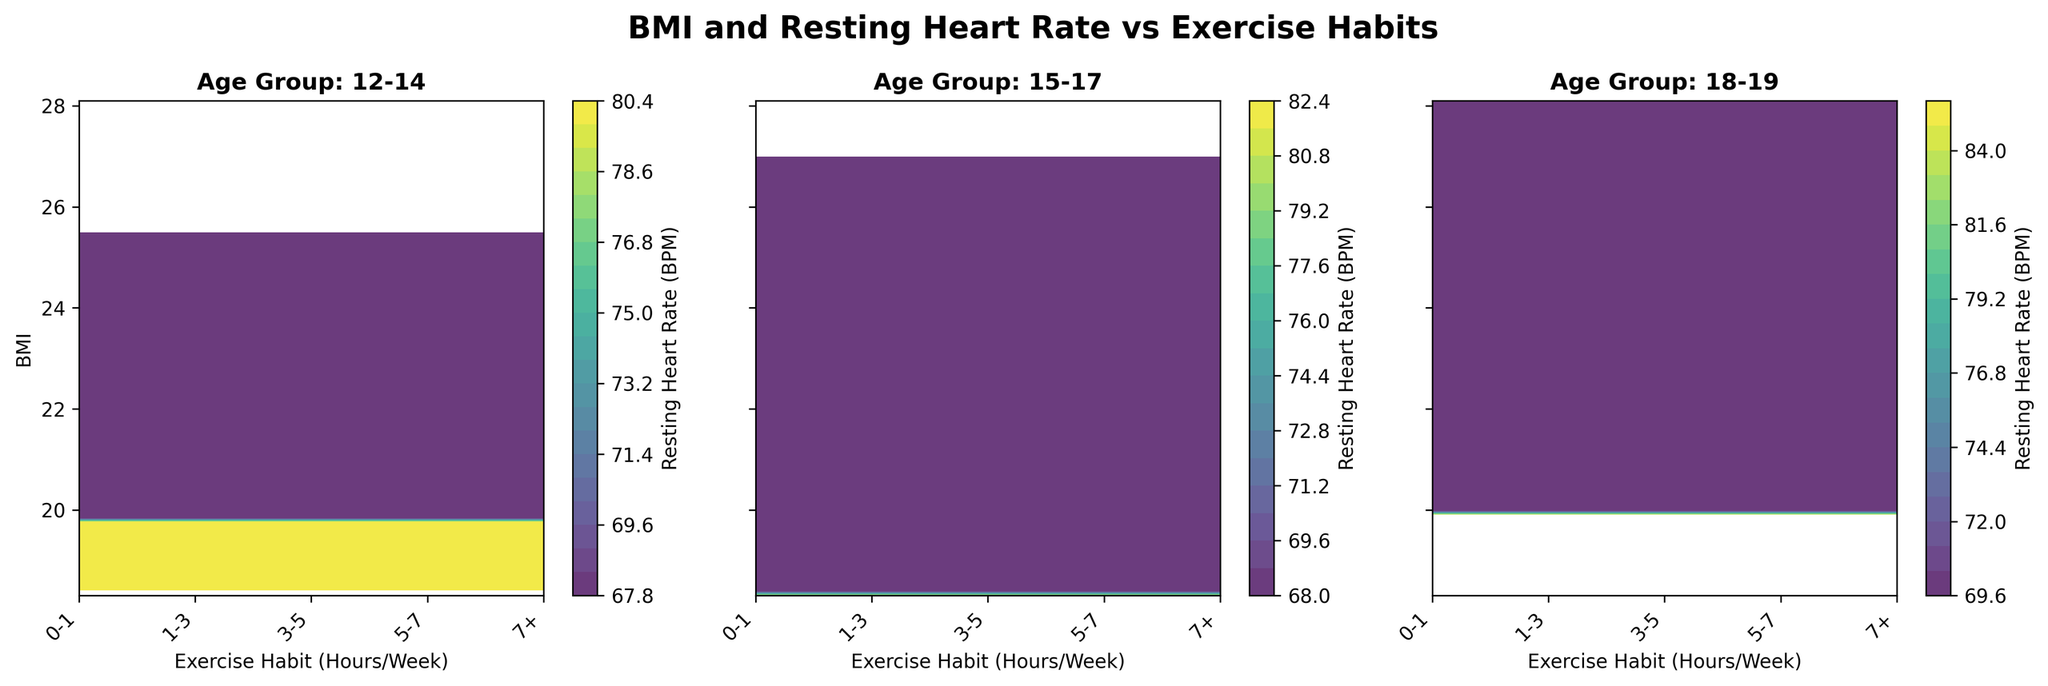What is the title of the figure? The title of the figure is displayed at the top of the plot and reads "BMI and Resting Heart Rate vs Exercise Habits".
Answer: BMI and Resting Heart Rate vs Exercise Habits Which age group exhibits the lowest BMI for those who exercise 7+ hours a week? Look at the subplot for each age group and find the BMI value corresponding to the 7+ exercise habit. The age group with the lowest BMI for 7+ hours of exercise is "15-17".
Answer: 15-17 What does the color represent in the subplots? The color in the subplots represents the Resting Heart Rate in BPM, as indicated by the color bar on the right side of each subplot.
Answer: Resting Heart Rate (BPM) How do the BMI values for the '12-14' age group change with increasing weekly exercise hours? Observing the contour plot for the '12-14' age group, the BMI values generally decrease and then slightly increase as the exercise hours increase from 0-1 to 7+ hours.
Answer: Decrease then slight increase Which age group has the highest resting heart rate for the 0-1 hours/week exercise category? By comparing the values in the color bar for each age group at the 0-1 exercise category, we can see that the '18-19' age group has the highest resting heart rate in this category.
Answer: 18-19 Does any age group show a consistent decrease in resting heart rate with increasing exercise habits? By examining the color gradients in each subplot, the '15-17' age group shows a consistent decrease in resting heart rate with increasing exercise habits.
Answer: 15-17 Which age group shows the most variability in resting heart rate across different exercise categories? By assessing the range of colors in each subplot, the '18-19' age group displays the widest range of resting heart rates across the different exercise categories.
Answer: 18-19 For the '15-17' age group, what is the difference in resting heart rate between those who exercise 0-1 hours/week and those who exercise 7+ hours/week? To find the difference, look at the resting heart rate values for the '15-17' age group at the 0-1 hours/week and 7+ hours/week categories. The difference is 82 BPM (0-1 hours/week) - 68 BPM (7+ hours/week) = 14 BPM.
Answer: 14 BPM 